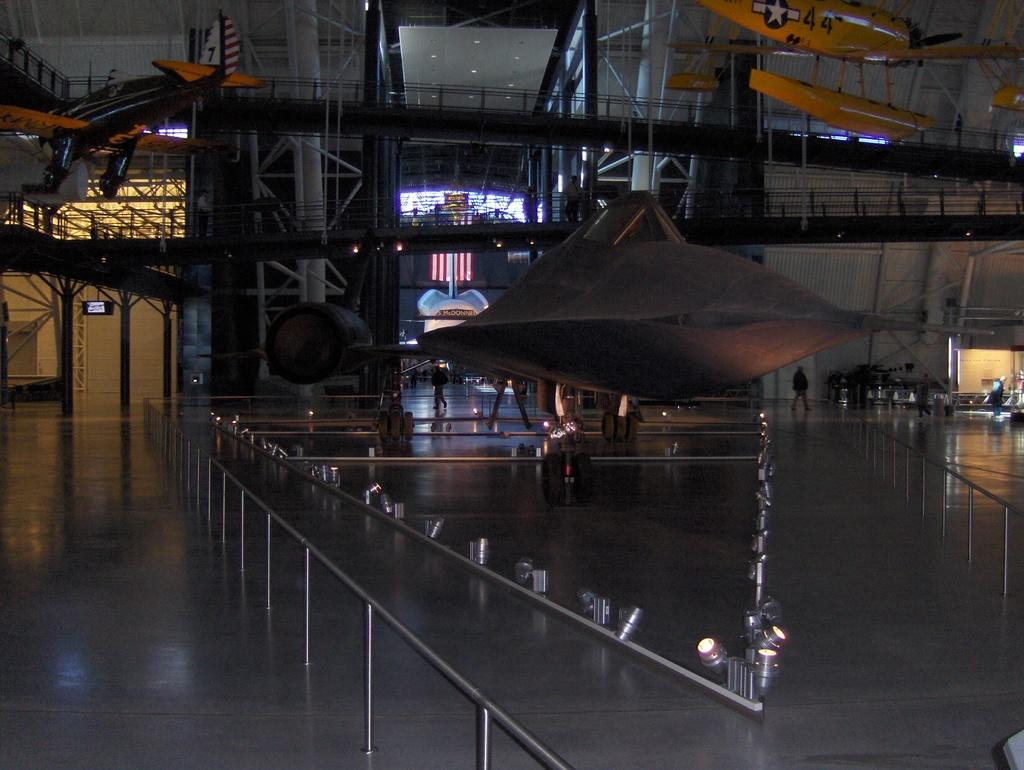What is hanging in the image? There are aircrafts hanging in the image. What can be seen near the aircrafts? There are railings in the image. What is visible in the background of the image? In the background, there are people, rods, pillars, and lights. Where can the fish be found in the image? There are no fish present in the image. What type of spoon is being used by the people in the image? There are no spoons visible in the image, and no people are shown using any utensils. 